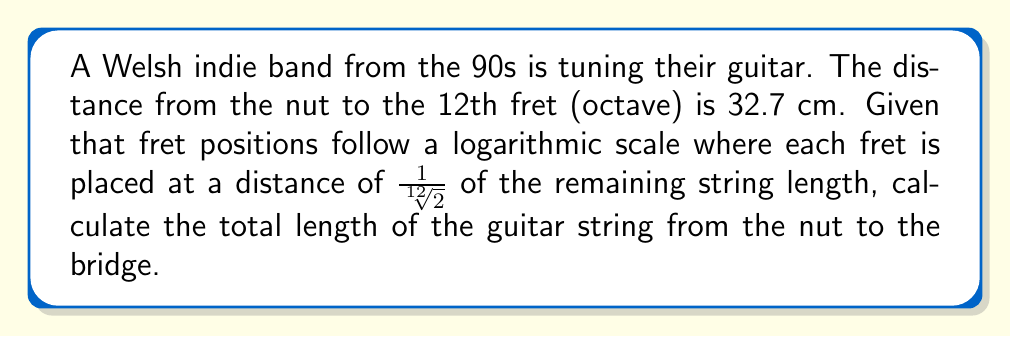Teach me how to tackle this problem. Let's approach this step-by-step:

1) First, recall that the 12th fret (octave) is exactly halfway along the string length. This means that the distance from the nut to the 12th fret is half the total string length.

2) We're given that the distance from the nut to the 12th fret is 32.7 cm. Let's call the total string length $L$. Then:

   $\frac{L}{2} = 32.7$ cm

3) To find $L$, we multiply both sides by 2:

   $L = 32.7 \times 2 = 65.4$ cm

4) We can verify this using the logarithmic scale property:

   The ratio of distances between consecutive frets is $\sqrt[12]{2} \approx 1.059463$

   The distance from the nut to the first fret would be:
   
   $L \times (1 - \frac{1}{\sqrt[12]{2}}) \approx 65.4 \times 0.0561 \approx 3.67$ cm

   The remaining string length after the first fret would be:
   
   $65.4 - 3.67 = 61.73$ cm

   You can continue this process for all 12 frets, and you'll find that the 12th fret indeed falls at 32.7 cm.

Therefore, the total length of the guitar string is 65.4 cm.
Answer: 65.4 cm 